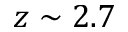<formula> <loc_0><loc_0><loc_500><loc_500>z \sim 2 . 7</formula> 